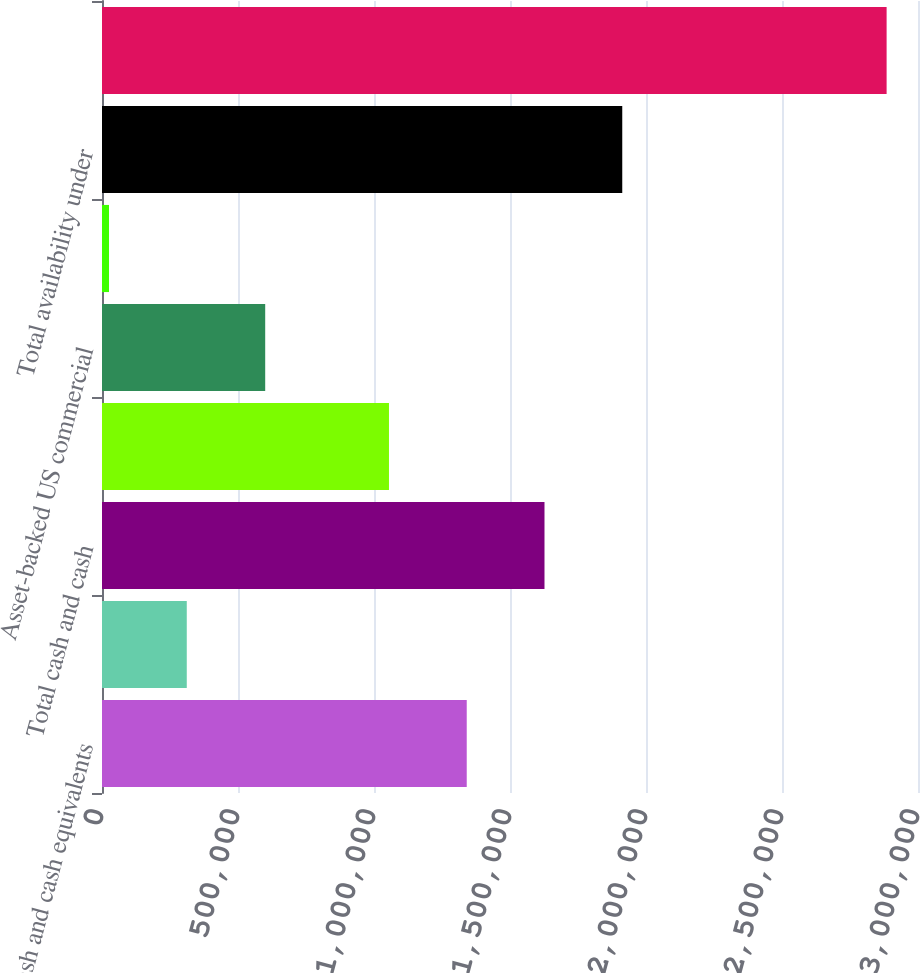Convert chart. <chart><loc_0><loc_0><loc_500><loc_500><bar_chart><fcel>Cash and cash equivalents<fcel>Marketable securities<fcel>Total cash and cash<fcel>Global credit facilities<fcel>Asset-backed US commercial<fcel>Asset-backed Canadian<fcel>Total availability under<fcel>Total<nl><fcel>1.34094e+06<fcel>311665<fcel>1.62682e+06<fcel>1.05506e+06<fcel>600000<fcel>25782<fcel>1.91271e+06<fcel>2.88461e+06<nl></chart> 